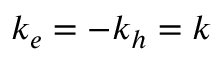Convert formula to latex. <formula><loc_0><loc_0><loc_500><loc_500>k _ { e } = - k _ { h } = k</formula> 